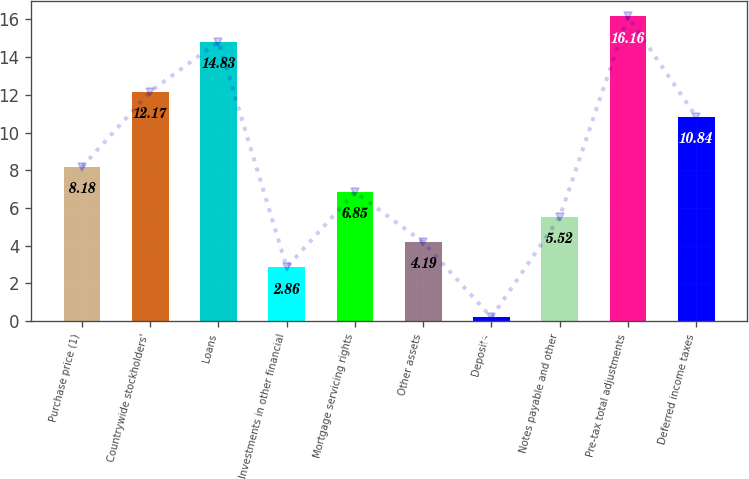Convert chart to OTSL. <chart><loc_0><loc_0><loc_500><loc_500><bar_chart><fcel>Purchase price (1)<fcel>Countrywide stockholders'<fcel>Loans<fcel>Investments in other financial<fcel>Mortgage servicing rights<fcel>Other assets<fcel>Deposits<fcel>Notes payable and other<fcel>Pre-tax total adjustments<fcel>Deferred income taxes<nl><fcel>8.18<fcel>12.17<fcel>14.83<fcel>2.86<fcel>6.85<fcel>4.19<fcel>0.2<fcel>5.52<fcel>16.16<fcel>10.84<nl></chart> 